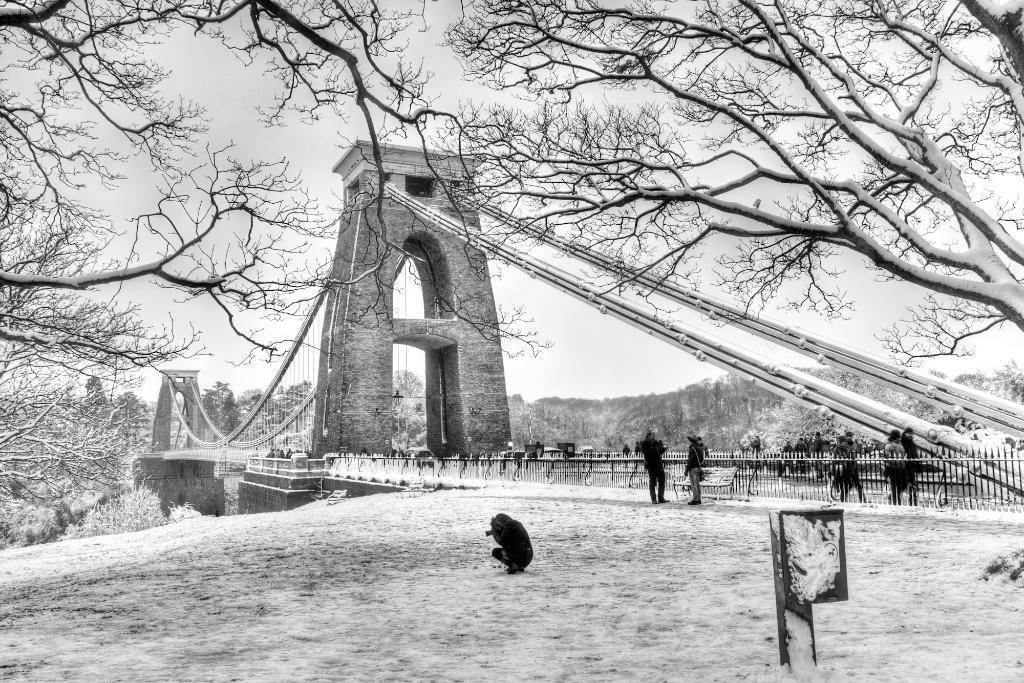Can you describe this image briefly? This is a black and white image. There is a bridge in the middle. There are trees in the middle. There is sky at the top. There are some persons standing in the middle. 